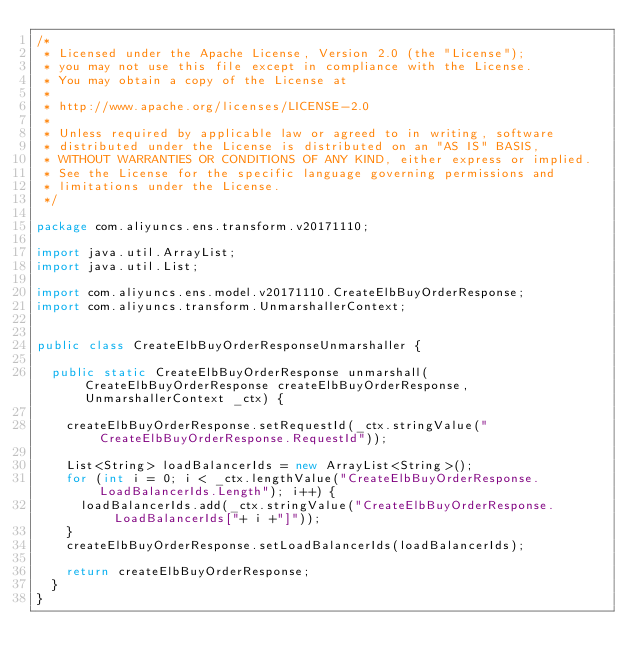<code> <loc_0><loc_0><loc_500><loc_500><_Java_>/*
 * Licensed under the Apache License, Version 2.0 (the "License");
 * you may not use this file except in compliance with the License.
 * You may obtain a copy of the License at
 *
 * http://www.apache.org/licenses/LICENSE-2.0
 *
 * Unless required by applicable law or agreed to in writing, software
 * distributed under the License is distributed on an "AS IS" BASIS,
 * WITHOUT WARRANTIES OR CONDITIONS OF ANY KIND, either express or implied.
 * See the License for the specific language governing permissions and
 * limitations under the License.
 */

package com.aliyuncs.ens.transform.v20171110;

import java.util.ArrayList;
import java.util.List;

import com.aliyuncs.ens.model.v20171110.CreateElbBuyOrderResponse;
import com.aliyuncs.transform.UnmarshallerContext;


public class CreateElbBuyOrderResponseUnmarshaller {

	public static CreateElbBuyOrderResponse unmarshall(CreateElbBuyOrderResponse createElbBuyOrderResponse, UnmarshallerContext _ctx) {
		
		createElbBuyOrderResponse.setRequestId(_ctx.stringValue("CreateElbBuyOrderResponse.RequestId"));

		List<String> loadBalancerIds = new ArrayList<String>();
		for (int i = 0; i < _ctx.lengthValue("CreateElbBuyOrderResponse.LoadBalancerIds.Length"); i++) {
			loadBalancerIds.add(_ctx.stringValue("CreateElbBuyOrderResponse.LoadBalancerIds["+ i +"]"));
		}
		createElbBuyOrderResponse.setLoadBalancerIds(loadBalancerIds);
	 
	 	return createElbBuyOrderResponse;
	}
}</code> 